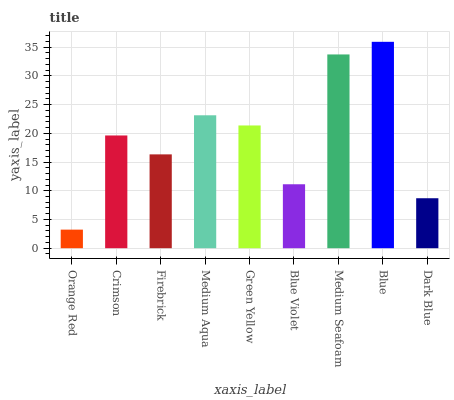Is Orange Red the minimum?
Answer yes or no. Yes. Is Blue the maximum?
Answer yes or no. Yes. Is Crimson the minimum?
Answer yes or no. No. Is Crimson the maximum?
Answer yes or no. No. Is Crimson greater than Orange Red?
Answer yes or no. Yes. Is Orange Red less than Crimson?
Answer yes or no. Yes. Is Orange Red greater than Crimson?
Answer yes or no. No. Is Crimson less than Orange Red?
Answer yes or no. No. Is Crimson the high median?
Answer yes or no. Yes. Is Crimson the low median?
Answer yes or no. Yes. Is Green Yellow the high median?
Answer yes or no. No. Is Medium Seafoam the low median?
Answer yes or no. No. 